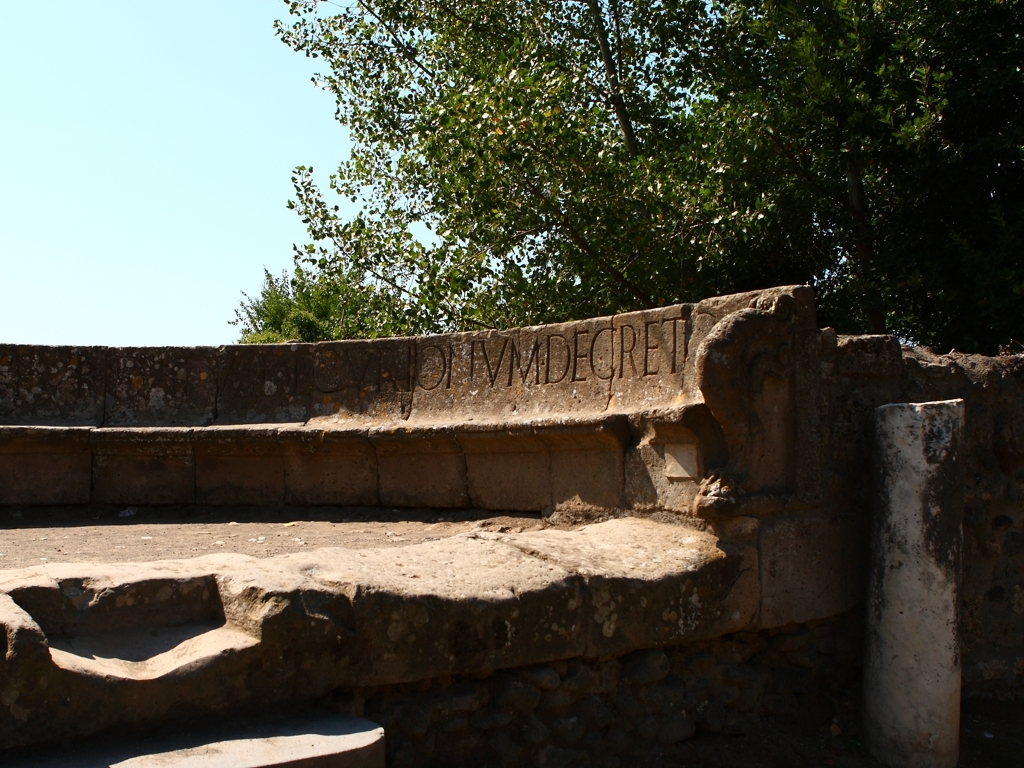Could this structure have had a ceremonial or communal purpose? It's plausible that the structure served as a communal gathering place given its amphitheater-like steps and prominent location. Ancient civilizations tended to build open-air venues for cultural or ceremonial events including forums, marketplaces, theaters, or meeting spaces, indicating a highly social and organized community structure. What material appears to have been used in the construction of this structure? The structure appears to be primarily made of stone, which is expected for constructions from ancient times. The choice of stone indicates a pursuit of durability and a representation of permanence. Stonework from this era often showcases the advanced masonry skills and techniques used to create enduring monuments. 